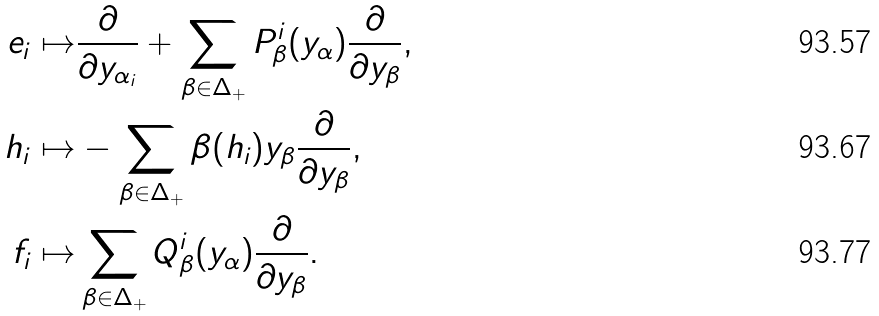<formula> <loc_0><loc_0><loc_500><loc_500>e _ { i } \mapsto & \frac { \partial } { \partial y _ { \alpha _ { i } } } + \sum _ { \beta \in \Delta _ { + } } P _ { \beta } ^ { i } ( y _ { \alpha } ) \frac { \partial } { \partial y _ { \beta } } , \\ h _ { i } \mapsto & - \sum _ { \beta \in \Delta _ { + } } \beta ( h _ { i } ) y _ { \beta } \frac { \partial } { \partial y _ { \beta } } , \\ f _ { i } \mapsto & \sum _ { \beta \in \Delta _ { + } } Q _ { \beta } ^ { i } ( y _ { \alpha } ) \frac { \partial } { \partial y _ { \beta } } .</formula> 